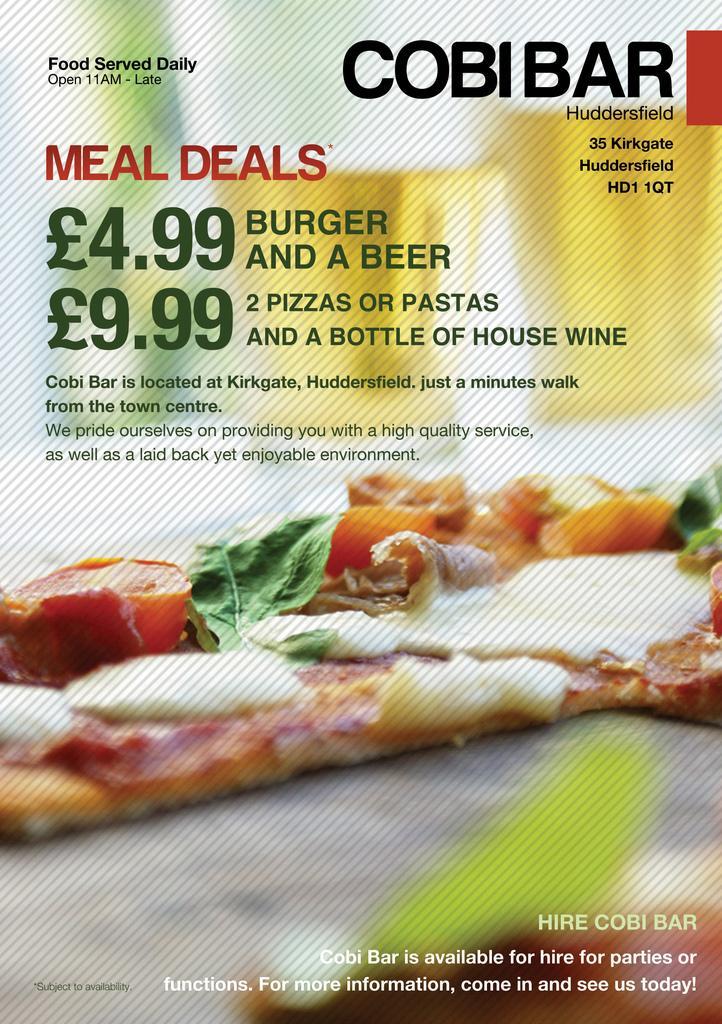Can you describe this image briefly? This image consists of a poster on which there is a picture of food. At the top, there is a text. 